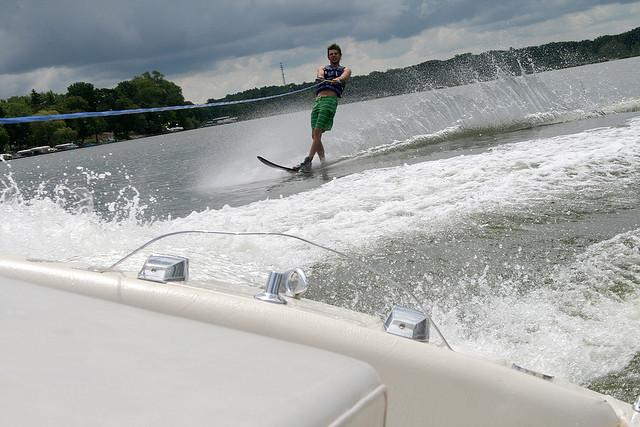What powers the vessel pulling the skier? Please explain your reasoning. boat motor. The boat motor is powering. 